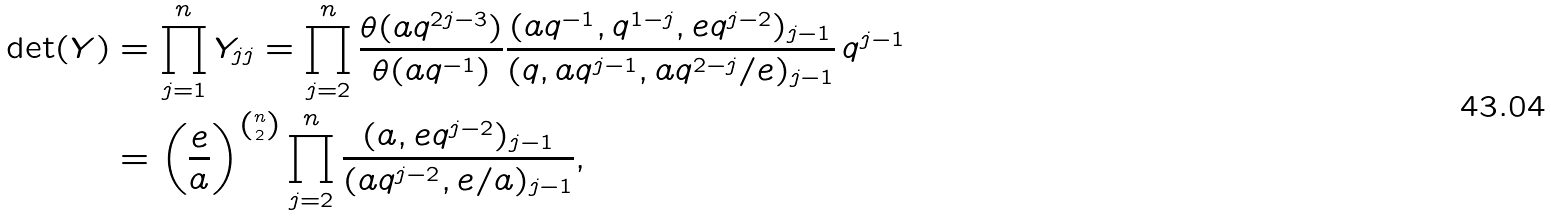Convert formula to latex. <formula><loc_0><loc_0><loc_500><loc_500>\det ( Y ) & = \prod _ { j = 1 } ^ { n } Y _ { j j } = \prod _ { j = 2 } ^ { n } \frac { \theta ( a q ^ { 2 j - 3 } ) } { \theta ( a q ^ { - 1 } ) } \frac { ( a q ^ { - 1 } , q ^ { 1 - j } , e q ^ { j - 2 } ) _ { j - 1 } } { ( q , a q ^ { j - 1 } , a q ^ { 2 - j } / e ) _ { j - 1 } } \, q ^ { j - 1 } \\ & = \left ( \frac { e } { a } \right ) ^ { \binom { n } { 2 } } \prod _ { j = 2 } ^ { n } \frac { ( a , e q ^ { j - 2 } ) _ { j - 1 } } { ( a q ^ { j - 2 } , e / a ) _ { j - 1 } } ,</formula> 